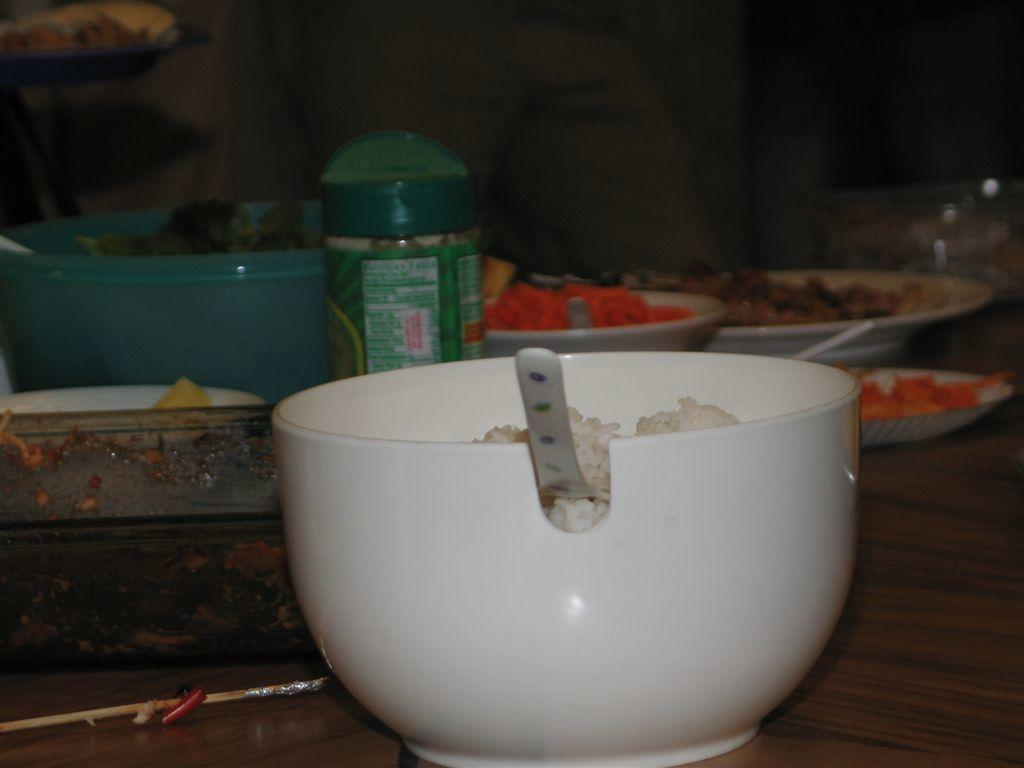What type of container is visible in the image? There is a bowl in the image. What other objects can be seen in the image? There is a bottle and a plate in the image. Is there any decoration or labeling on any of the objects? Yes, there is a sticker in the image. How would you describe the overall appearance of the image? The background of the image is dark. What type of sound can be heard coming from the neck in the image? There is no neck or sound present in the image. Can you describe the skateboarding activity happening in the image? There is no skateboarding activity or skateboard present in the image. 